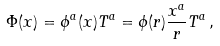<formula> <loc_0><loc_0><loc_500><loc_500>\Phi ( x ) = \phi ^ { a } ( x ) T ^ { a } = \phi ( r ) \frac { x ^ { a } } { r } T ^ { a } \, ,</formula> 